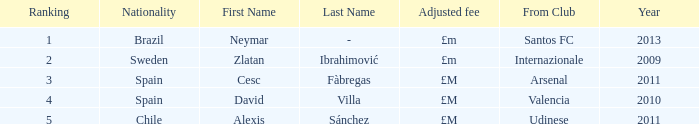What is the homeland of the player ranked 2? Internazionale. 